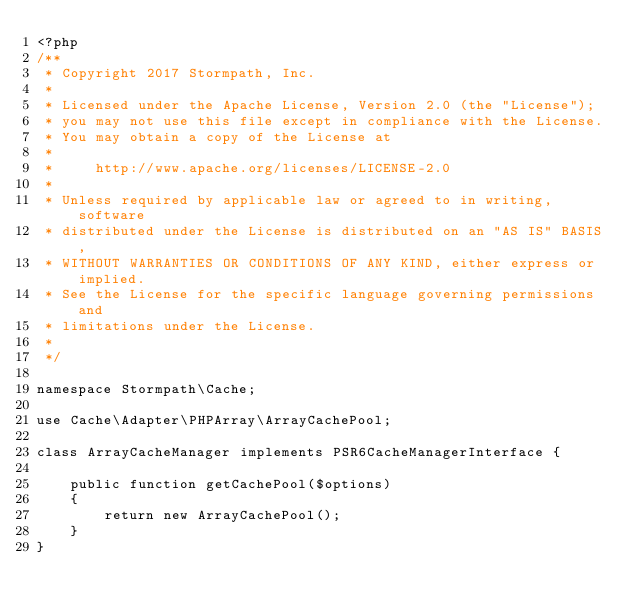Convert code to text. <code><loc_0><loc_0><loc_500><loc_500><_PHP_><?php
/**
 * Copyright 2017 Stormpath, Inc.
 *
 * Licensed under the Apache License, Version 2.0 (the "License");
 * you may not use this file except in compliance with the License.
 * You may obtain a copy of the License at
 *
 *     http://www.apache.org/licenses/LICENSE-2.0
 *
 * Unless required by applicable law or agreed to in writing, software
 * distributed under the License is distributed on an "AS IS" BASIS,
 * WITHOUT WARRANTIES OR CONDITIONS OF ANY KIND, either express or implied.
 * See the License for the specific language governing permissions and
 * limitations under the License.
 *
 */

namespace Stormpath\Cache;

use Cache\Adapter\PHPArray\ArrayCachePool;

class ArrayCacheManager implements PSR6CacheManagerInterface {

    public function getCachePool($options)
    {
        return new ArrayCachePool();
    }
}
</code> 